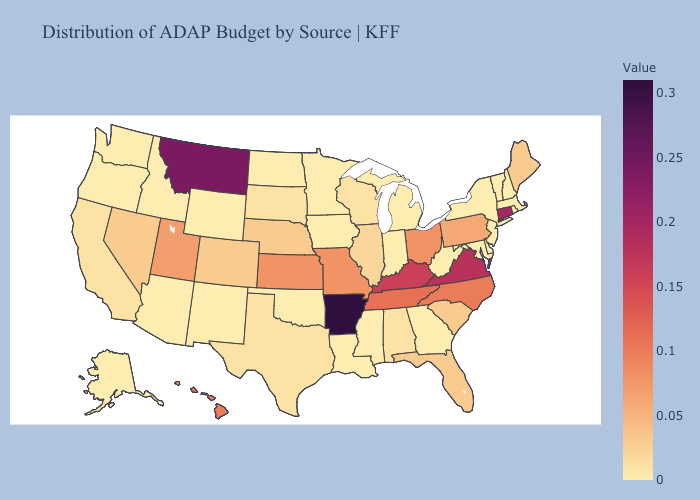Which states have the lowest value in the Northeast?
Answer briefly. Massachusetts, New Hampshire, New Jersey, New York, Rhode Island, Vermont. Does South Carolina have the lowest value in the South?
Give a very brief answer. No. Does New Hampshire have the lowest value in the USA?
Keep it brief. Yes. Is the legend a continuous bar?
Be succinct. Yes. Does Arkansas have the highest value in the USA?
Give a very brief answer. Yes. Among the states that border Tennessee , does Alabama have the lowest value?
Quick response, please. No. Does Arkansas have the lowest value in the USA?
Give a very brief answer. No. 